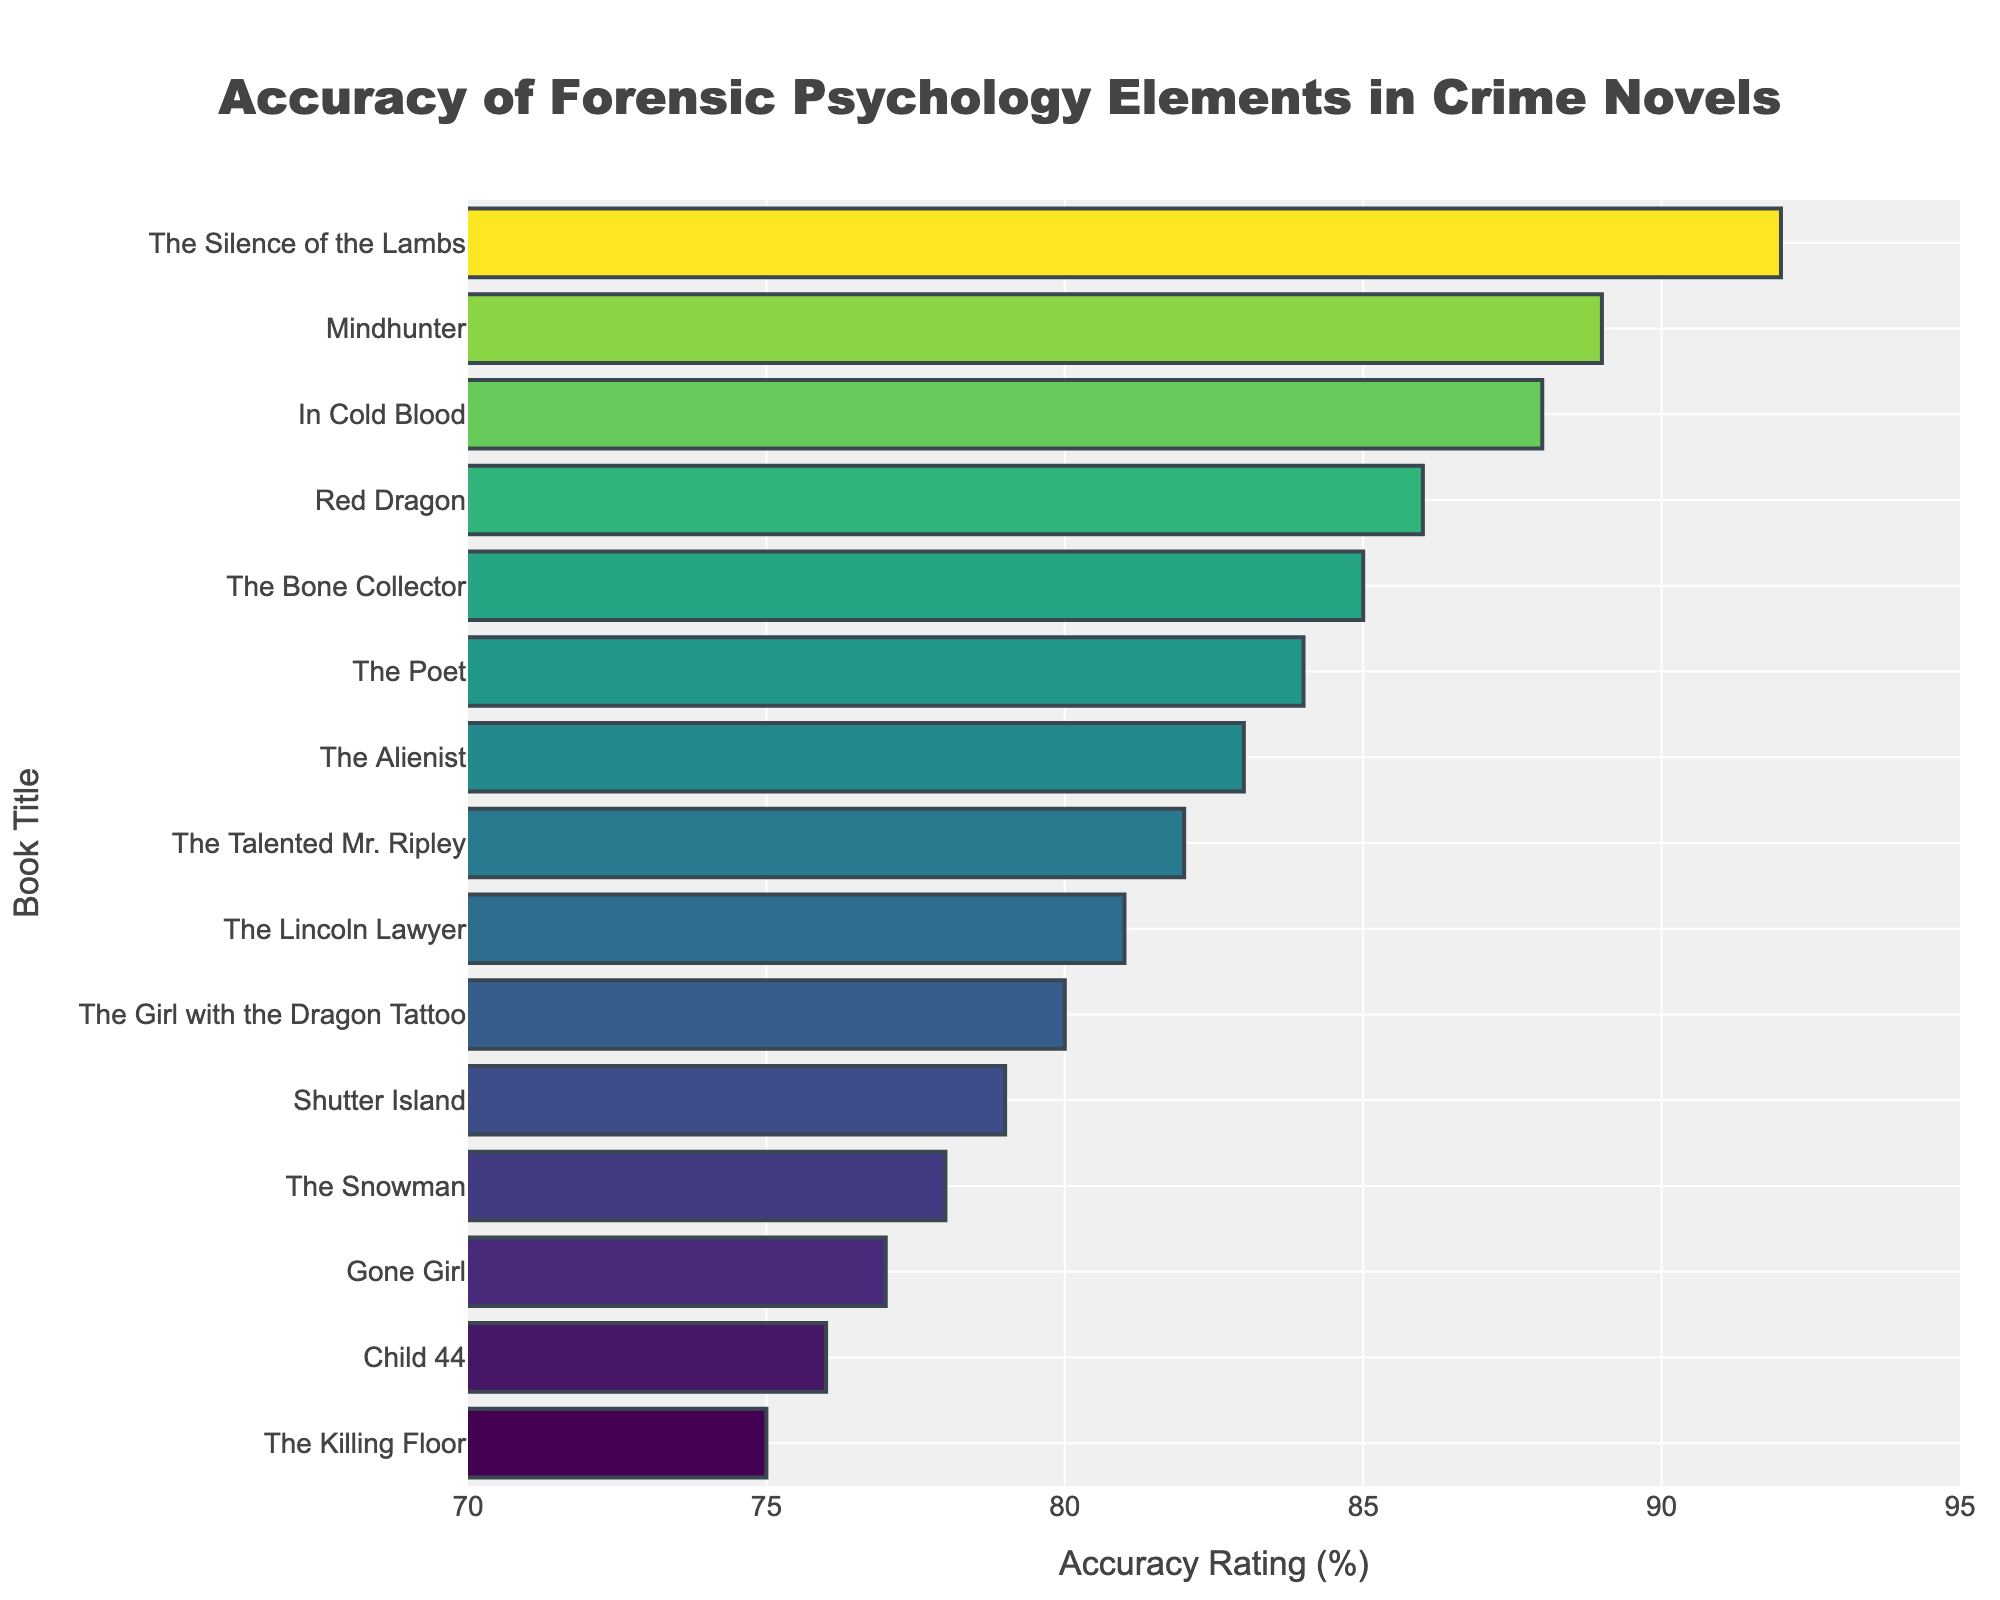Which book has the highest accuracy rating? The book with the highest accuracy rating is "The Silence of the Lambs" with a rating of 92%. This can be seen at the top of the bar chart as it is sorted in descending order.
Answer: The Silence of the Lambs What is the average accuracy rating of the top 5 books? The top 5 books are "The Silence of the Lambs" (92), "Mindhunter" (89), "In Cold Blood" (88), "Red Dragon" (86), and "The Bone Collector" (85). Adding these values gives 92 + 89 + 88 + 86 + 85 = 440. The average is found by dividing this sum by 5, so 440 / 5 = 88.
Answer: 88 Which book has a higher accuracy rating, "The Girl with the Dragon Tattoo" or "Gone Girl"? Referring to the chart, "The Girl with the Dragon Tattoo" has an accuracy rating of 80%, while "Gone Girl" has a rating of 77%. Therefore, "The Girl with the Dragon Tattoo" has a higher rating than "Gone Girl".
Answer: The Girl with the Dragon Tattoo How many books have an accuracy rating greater than or equal to 85%? The books with accuracy ratings of 85% or higher are "The Silence of the Lambs" (92), "Mindhunter" (89), "In Cold Blood" (88), "Red Dragon" (86), and "The Bone Collector" (85). Counting these gives 5 books in total.
Answer: 5 What is the range of the accuracy ratings shown in the chart? The lowest accuracy rating is for "The Killing Floor" with 75%, and the highest is for "The Silence of the Lambs" with 92%. The range is found by subtracting the lowest rating from the highest, so 92 - 75 = 17.
Answer: 17 What is the median accuracy rating of all the books? To find the median, we must first list the ratings in order: 75, 76, 77, 78, 79, 80, 81, 82, 83, 84, 85, 86, 88, 89, 92. With 15 values, the median is the 8th value, which is 81.
Answer: 81 Which book has more accurate forensic psychology elements, "Shutter Island" or "The Snowman"? According to the chart, "Shutter Island" has an accuracy rating of 79%, while "The Snowman" has a rating of 78%. Hence, "Shutter Island" has more accurate forensic psychology elements than "The Snowman".
Answer: Shutter Island Is the accuracy rating of "Child 44" less than the average rating of all books? First, we need to calculate the average rating. The sum of all ratings is 1240 (obtained by adding individual ratings: 92 + 89 + 88 + 86 + 85 + 83 + 82 + 81 + 80 + 79 + 78 + 77 + 76 + 75 + 84). The average rating is 1240 / 15 = 82.67. The accuracy rating of "Child 44" is 76, which is less than the average rating of 82.67.
Answer: Yes Which book has the closest accuracy rating to 80% without going over? From the chart, the book with the accuracy rating closest to 80% without going over is "The Girl with the Dragon Tattoo," which has an accuracy rating of exactly 80%.
Answer: The Girl with the Dragon Tattoo 